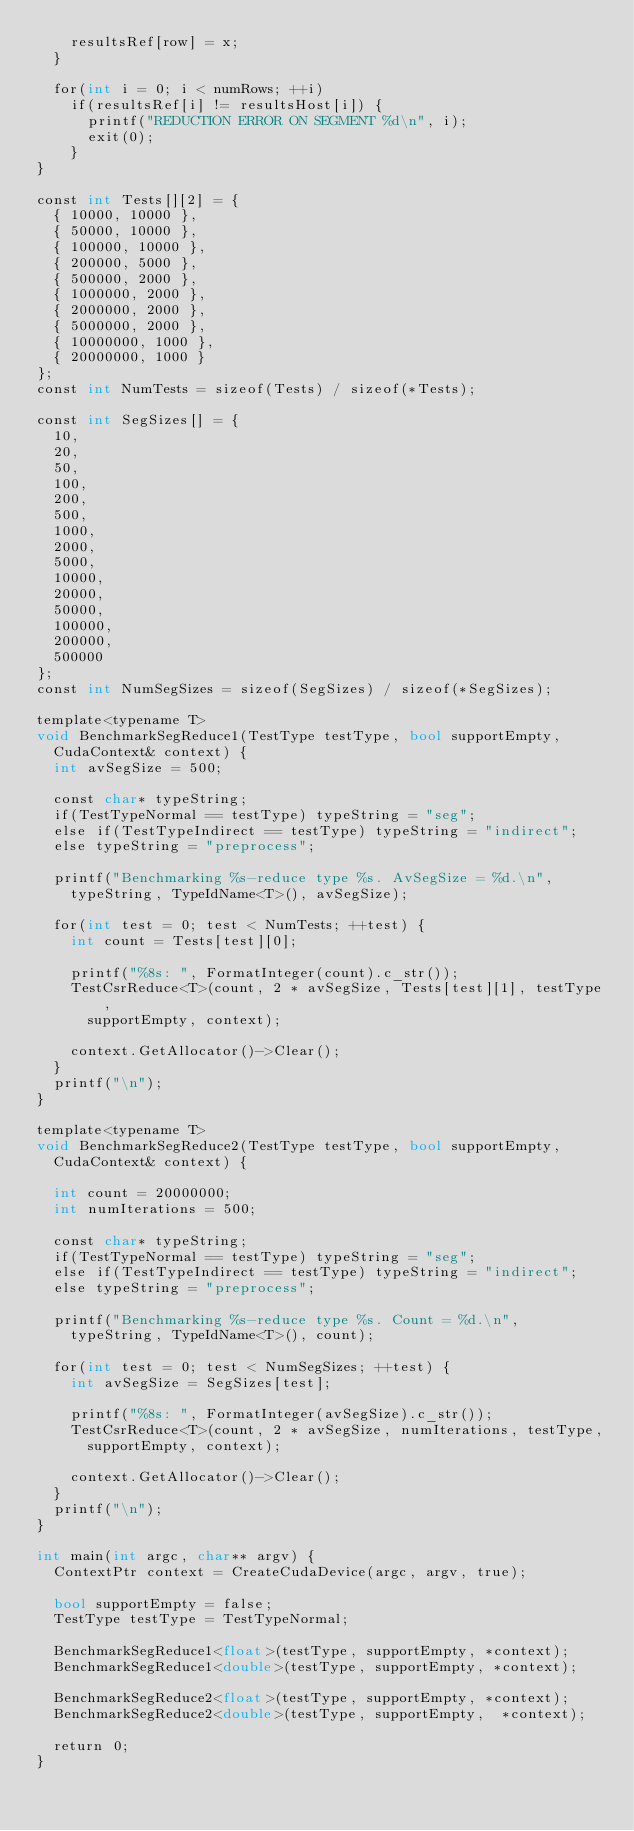Convert code to text. <code><loc_0><loc_0><loc_500><loc_500><_Cuda_>		resultsRef[row] = x;
	}
	
	for(int i = 0; i < numRows; ++i)
		if(resultsRef[i] != resultsHost[i]) {
			printf("REDUCTION ERROR ON SEGMENT %d\n", i);
			exit(0);
		}
}

const int Tests[][2] = { 
	{ 10000, 10000 },
	{ 50000, 10000 },
	{ 100000, 10000 },
	{ 200000, 5000 },
	{ 500000, 2000 },
	{ 1000000, 2000 },
	{ 2000000, 2000 },
	{ 5000000, 2000 },
	{ 10000000, 1000 },
	{ 20000000, 1000 }
};
const int NumTests = sizeof(Tests) / sizeof(*Tests); 

const int SegSizes[] = { 
	10,
	20,
	50,
	100,
	200,
	500,
	1000,
	2000,
	5000,
	10000,
	20000,
	50000,
	100000,
	200000,
	500000
};
const int NumSegSizes = sizeof(SegSizes) / sizeof(*SegSizes);

template<typename T>
void BenchmarkSegReduce1(TestType testType, bool supportEmpty, 
	CudaContext& context) {
	int avSegSize = 500;
	
	const char* typeString;
	if(TestTypeNormal == testType) typeString = "seg";
	else if(TestTypeIndirect == testType) typeString = "indirect";
	else typeString = "preprocess";

	printf("Benchmarking %s-reduce type %s. AvSegSize = %d.\n",
		typeString, TypeIdName<T>(), avSegSize);
	 
	for(int test = 0; test < NumTests; ++test) {
		int count = Tests[test][0];

		printf("%8s: ", FormatInteger(count).c_str());
		TestCsrReduce<T>(count, 2 * avSegSize, Tests[test][1], testType,
			supportEmpty, context);

		context.GetAllocator()->Clear();
	}
	printf("\n");
}

template<typename T>
void BenchmarkSegReduce2(TestType testType, bool supportEmpty, 
	CudaContext& context) {

	int count = 20000000;
	int numIterations = 500;
	
	const char* typeString;
	if(TestTypeNormal == testType) typeString = "seg";
	else if(TestTypeIndirect == testType) typeString = "indirect";
	else typeString = "preprocess";

	printf("Benchmarking %s-reduce type %s. Count = %d.\n",
		typeString, TypeIdName<T>(), count);
	
	for(int test = 0; test < NumSegSizes; ++test) {
		int avSegSize = SegSizes[test];
		
		printf("%8s: ", FormatInteger(avSegSize).c_str());
		TestCsrReduce<T>(count, 2 * avSegSize, numIterations, testType,
			supportEmpty, context);
		
		context.GetAllocator()->Clear();
	}
	printf("\n");
}

int main(int argc, char** argv) {
	ContextPtr context = CreateCudaDevice(argc, argv, true);

	bool supportEmpty = false;
	TestType testType = TestTypeNormal;

	BenchmarkSegReduce1<float>(testType, supportEmpty, *context);
	BenchmarkSegReduce1<double>(testType, supportEmpty, *context);

	BenchmarkSegReduce2<float>(testType, supportEmpty, *context);
	BenchmarkSegReduce2<double>(testType, supportEmpty,  *context);

	return 0;
}  </code> 